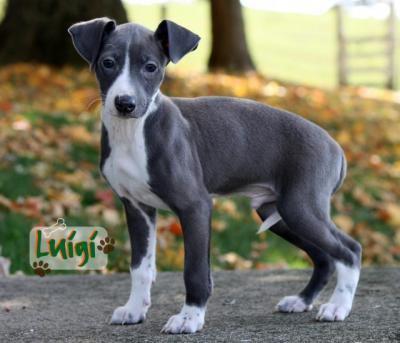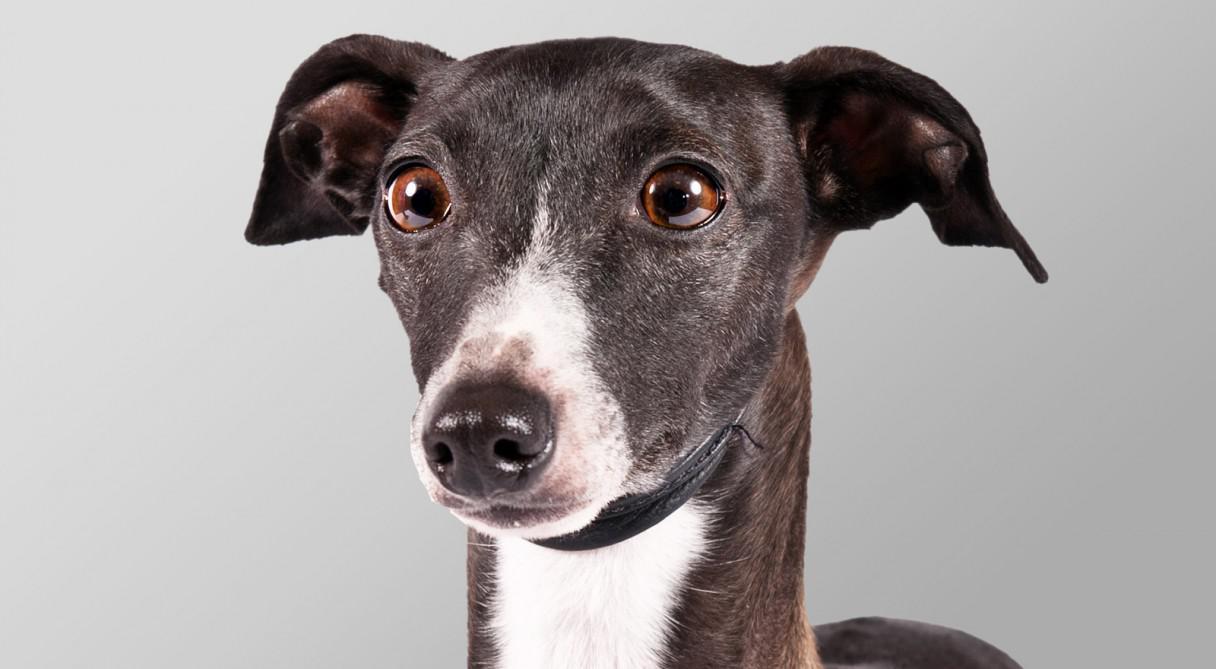The first image is the image on the left, the second image is the image on the right. For the images displayed, is the sentence "The dog on the left is posing for the picture outside on a sunny day." factually correct? Answer yes or no. Yes. The first image is the image on the left, the second image is the image on the right. Evaluate the accuracy of this statement regarding the images: "Each image contains exactly one dog, and the dog on the left is dark charcoal gray with white markings.". Is it true? Answer yes or no. Yes. 